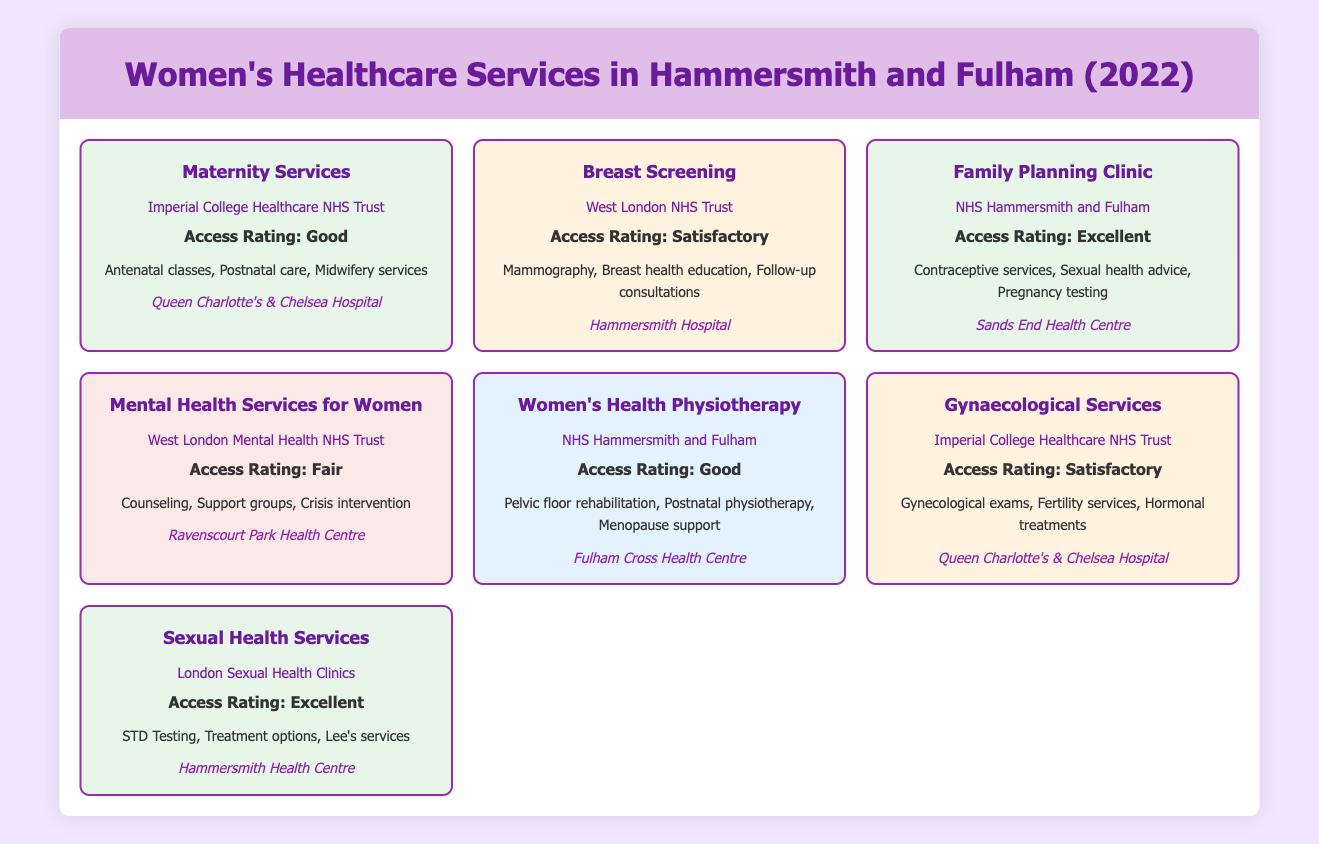What is the access rating for the Family Planning Clinic? The Family Planning Clinic is listed in the table under the 'Access Rating' section, which shows "Access Rating: Excellent."
Answer: Excellent Which service provides "Gynecological exams"? By checking the table, the service that offers "Gynecological exams" is identified under the "Gynaecological Services," provided by Imperial College Healthcare NHS Trust.
Answer: Gynaecological Services How many services have an access rating of "Satisfactory"? There are two services with the "Access Rating: Satisfactory"—Breast Screening and Gynaecological Services—so we count them.
Answer: 2 Is there a service that provides menopause support? The table indicates that "Women's Health Physiotherapy," provided by NHS Hammersmith and Fulham, offers menopause support as one of its facilities.
Answer: Yes What is the total number of services listed in the table? There are seven services listed in the table that cater to women's healthcare in Hammersmith and Fulham, counted directly from the entries.
Answer: 7 Which provider has the most services with a good rating? NHST Hammersmith and Fulham provides two services—Family Planning Clinic and Women's Health Physiotherapy—both of which have a good access rating. This makes it the provider with the highest number of services rated good.
Answer: NHS Hammersmith and Fulham What location is associated with the Sexual Health Services? By looking at the table, Sexual Health Services are located at "Hammersmith Health Centre."
Answer: Hammersmith Health Centre How does the access rating of Mental Health Services for Women compare to Women's Health Physiotherapy? Mental Health Services for Women has an "Access Rating: Fair," while Women's Health Physiotherapy has an "Access Rating: Good," indicating that the latter has a better rating.
Answer: Good is better than Fair 